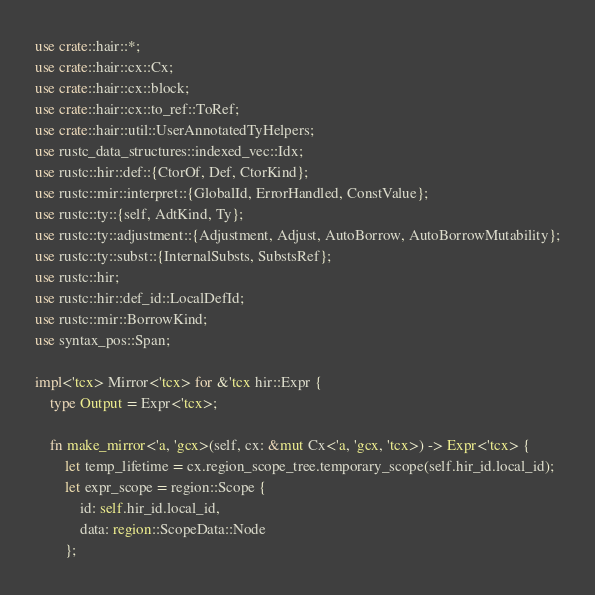<code> <loc_0><loc_0><loc_500><loc_500><_Rust_>use crate::hair::*;
use crate::hair::cx::Cx;
use crate::hair::cx::block;
use crate::hair::cx::to_ref::ToRef;
use crate::hair::util::UserAnnotatedTyHelpers;
use rustc_data_structures::indexed_vec::Idx;
use rustc::hir::def::{CtorOf, Def, CtorKind};
use rustc::mir::interpret::{GlobalId, ErrorHandled, ConstValue};
use rustc::ty::{self, AdtKind, Ty};
use rustc::ty::adjustment::{Adjustment, Adjust, AutoBorrow, AutoBorrowMutability};
use rustc::ty::subst::{InternalSubsts, SubstsRef};
use rustc::hir;
use rustc::hir::def_id::LocalDefId;
use rustc::mir::BorrowKind;
use syntax_pos::Span;

impl<'tcx> Mirror<'tcx> for &'tcx hir::Expr {
    type Output = Expr<'tcx>;

    fn make_mirror<'a, 'gcx>(self, cx: &mut Cx<'a, 'gcx, 'tcx>) -> Expr<'tcx> {
        let temp_lifetime = cx.region_scope_tree.temporary_scope(self.hir_id.local_id);
        let expr_scope = region::Scope {
            id: self.hir_id.local_id,
            data: region::ScopeData::Node
        };
</code> 